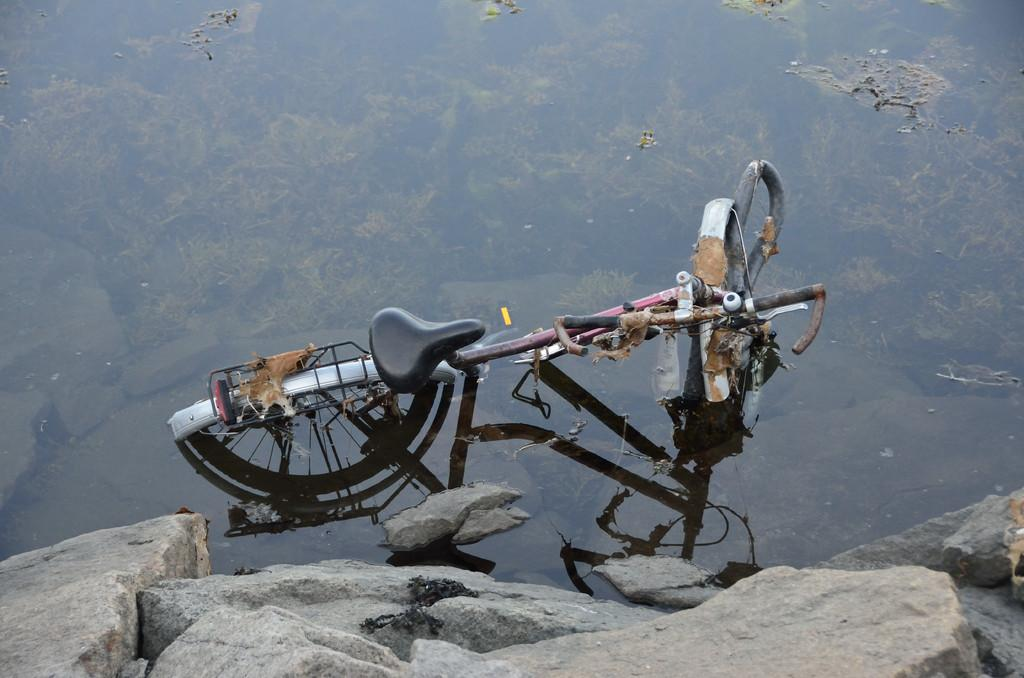What is the main object in the image? There is a bicycle in the image. What else can be seen in the image besides the bicycle? There are stones visible in the image. What type of jam is being spread on the bicycle in the image? There is no jam present in the image, and the bicycle is not being used for spreading jam. 